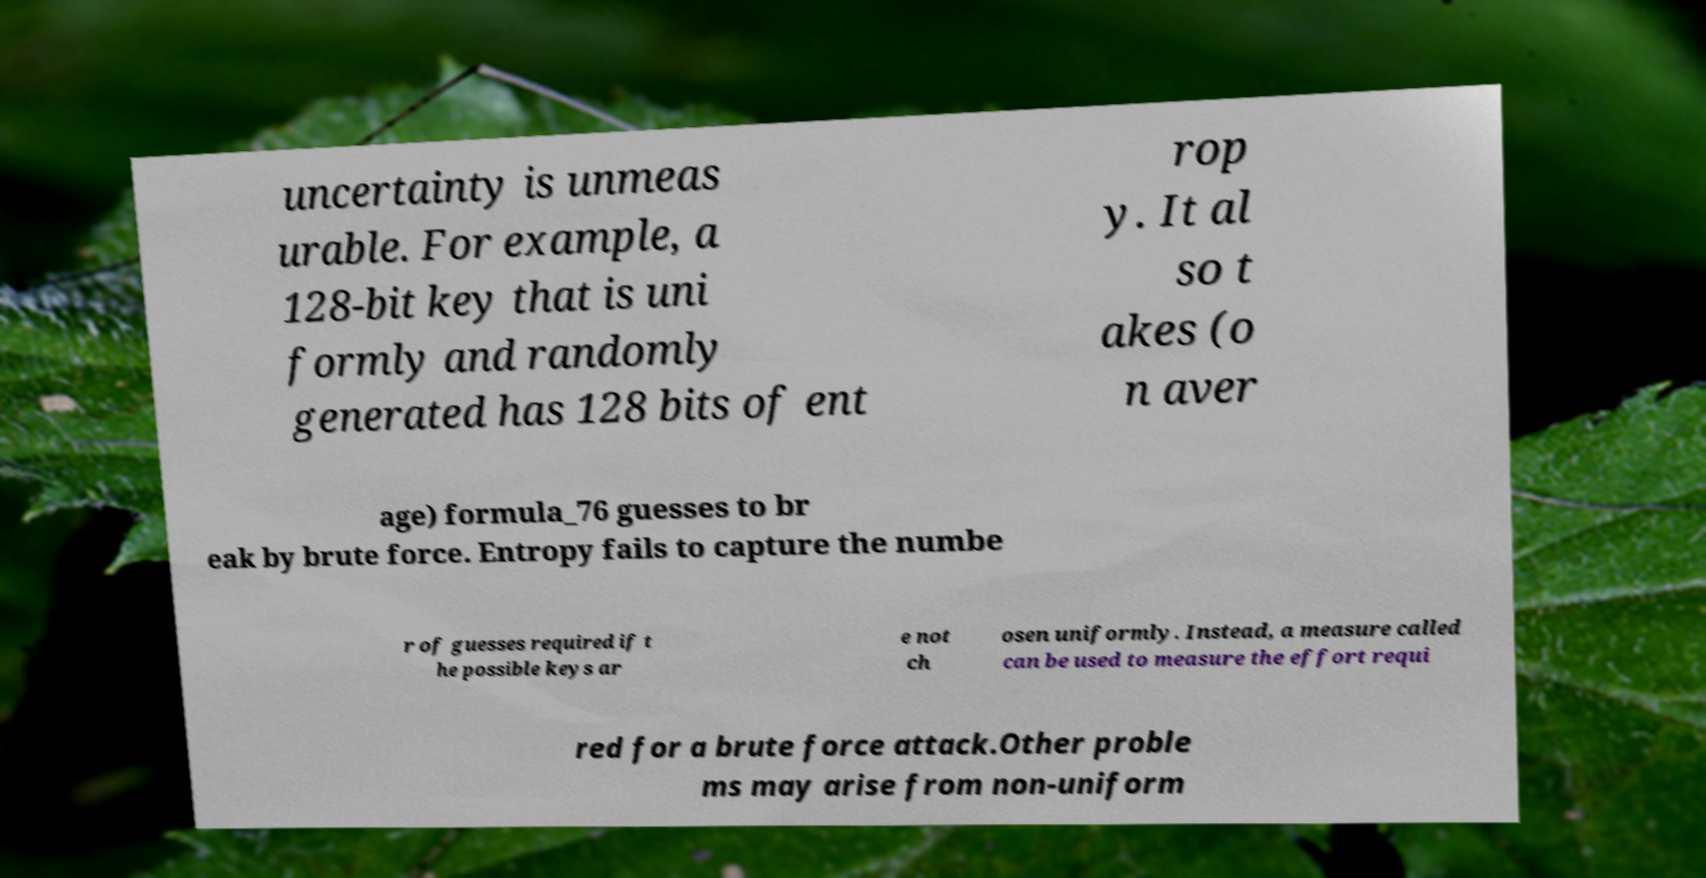Can you accurately transcribe the text from the provided image for me? uncertainty is unmeas urable. For example, a 128-bit key that is uni formly and randomly generated has 128 bits of ent rop y. It al so t akes (o n aver age) formula_76 guesses to br eak by brute force. Entropy fails to capture the numbe r of guesses required if t he possible keys ar e not ch osen uniformly. Instead, a measure called can be used to measure the effort requi red for a brute force attack.Other proble ms may arise from non-uniform 